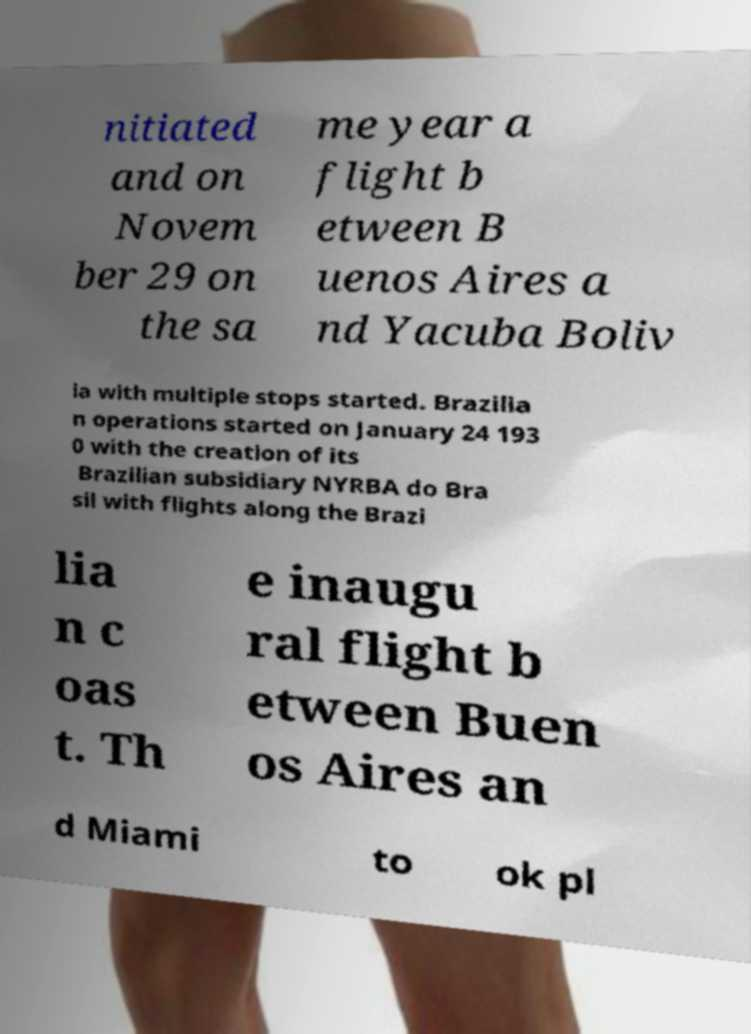Please identify and transcribe the text found in this image. nitiated and on Novem ber 29 on the sa me year a flight b etween B uenos Aires a nd Yacuba Boliv ia with multiple stops started. Brazilia n operations started on January 24 193 0 with the creation of its Brazilian subsidiary NYRBA do Bra sil with flights along the Brazi lia n c oas t. Th e inaugu ral flight b etween Buen os Aires an d Miami to ok pl 